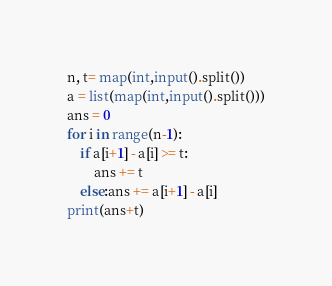Convert code to text. <code><loc_0><loc_0><loc_500><loc_500><_Python_>n, t= map(int,input().split())
a = list(map(int,input().split()))
ans = 0
for i in range(n-1):
    if a[i+1] - a[i] >= t:
        ans += t
    else:ans += a[i+1] - a[i]
print(ans+t)</code> 